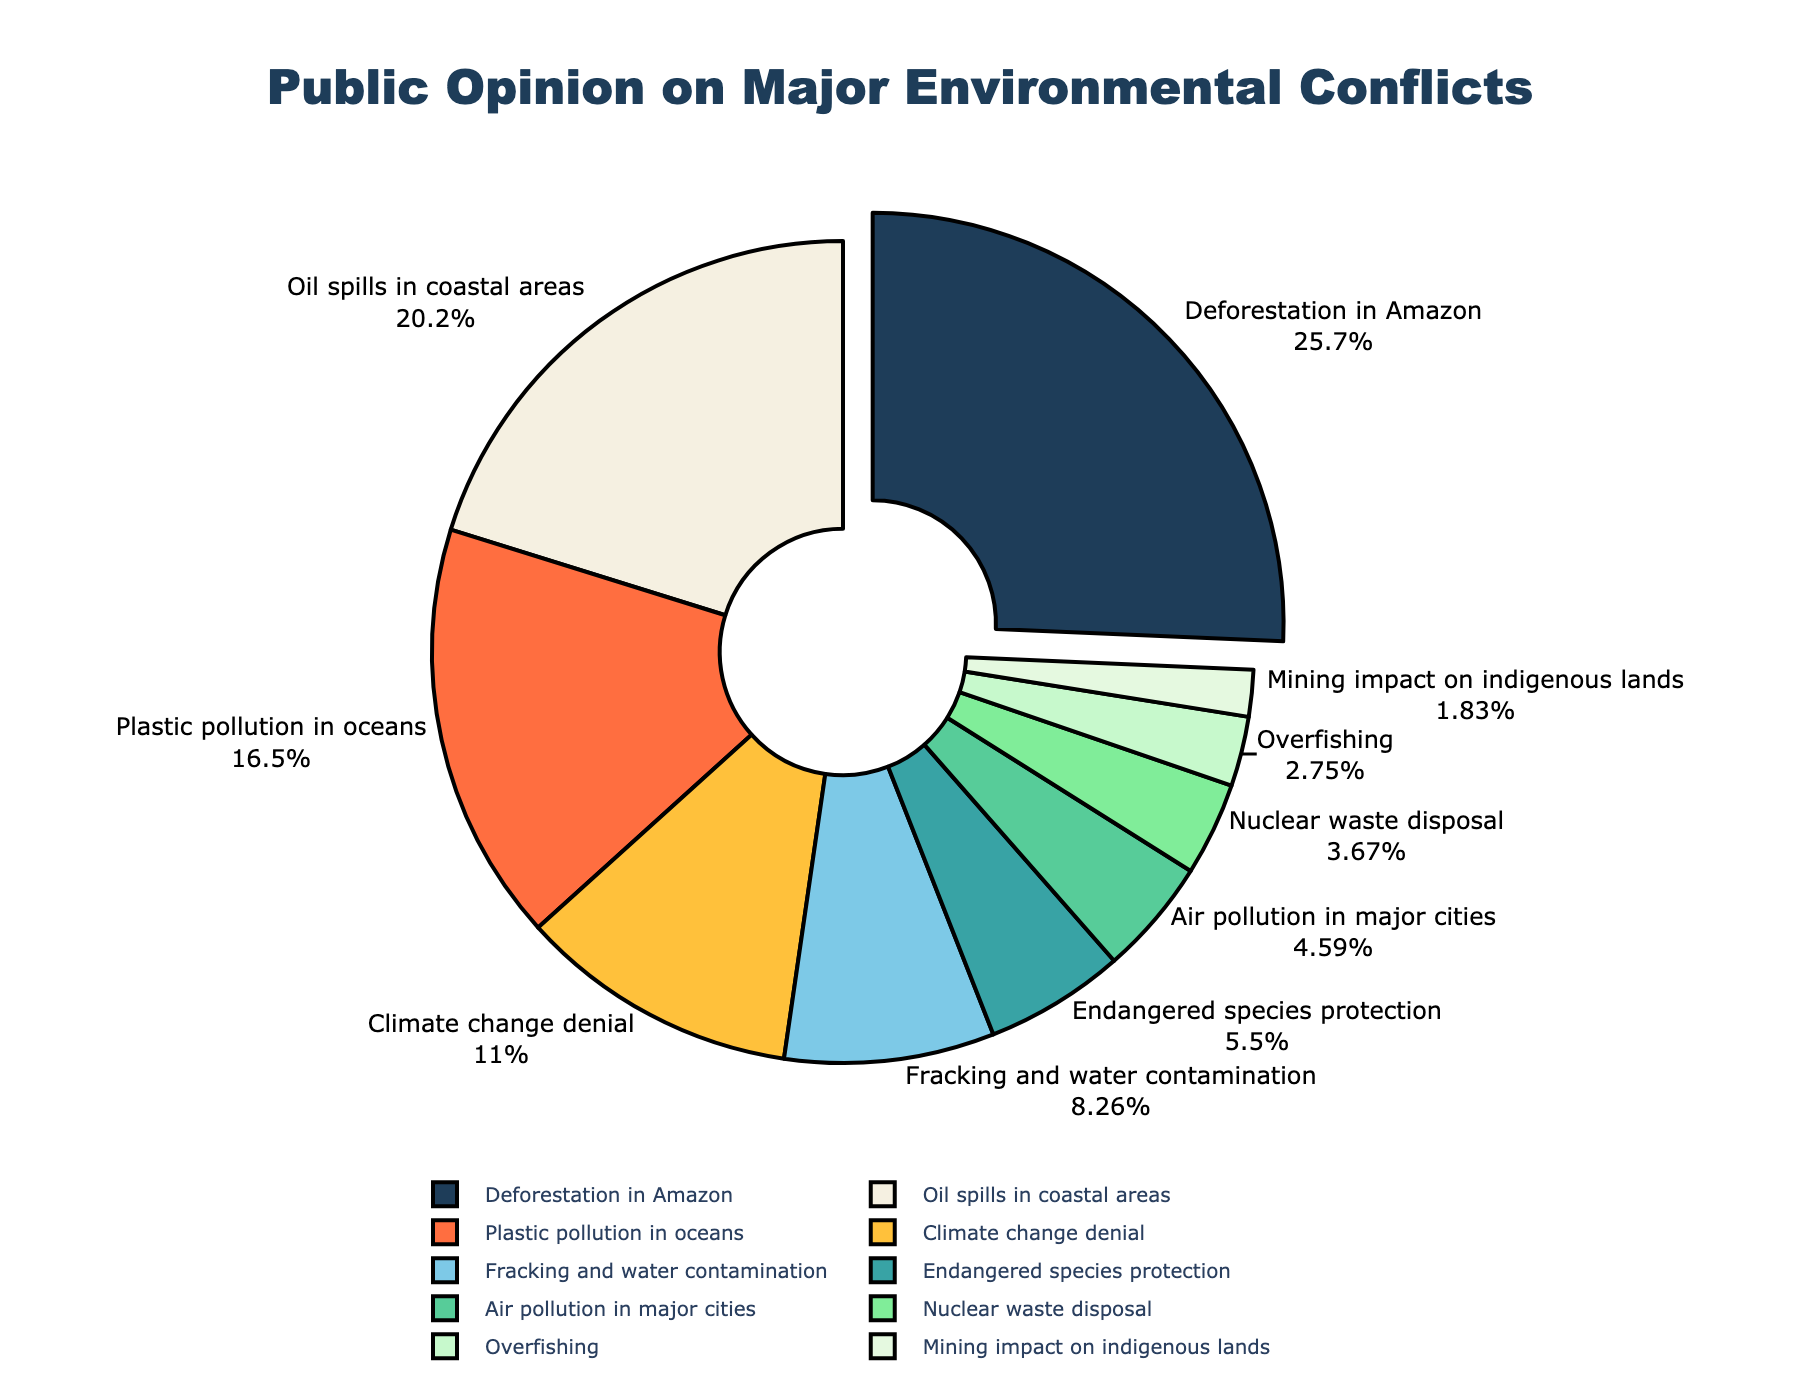Which environmental issue has the highest public concern? Referring to the figure, the largest portion of the pie chart, which is pulled out slightly from the rest, is for "Deforestation in Amazon" with 28%.
Answer: Deforestation in Amazon How much more concern is there for oil spills in coastal areas compared to fracking and water contamination? The percentage for oil spills in coastal areas is 22%, while for fracking and water contamination it is 9%. Subtracting these values, 22% - 9% = 13%.
Answer: 13% What is the combined percentage of concern for plastic pollution in oceans and climate change denial? The percentage for plastic pollution in oceans is 18%, and for climate change denial, it is 12%. Adding them, 18% + 12% = 30%.
Answer: 30% Which issue has a lower public concern: air pollution in major cities or nuclear waste disposal? Looking at the pie chart, air pollution in major cities has 5%, and nuclear waste disposal has 4%. Since 4% is less than 5%, nuclear waste disposal has a lower concern.
Answer: Nuclear waste disposal What fraction of the pie chart is dedicated to endangered species protection? Endangered species protection occupies 6% of the pie chart. To express this as a fraction, convert 6% to a fraction which is 6/100 or simplified to 3/50.
Answer: 3/50 How does public concern for overfishing compare to the concern for mining impact on indigenous lands? Overfishing has 3% and mining impact on indigenous lands has 2%. Since 3% is greater than 2%, overfishing is of more concern.
Answer: Overfishing What percentage of the pie chart corresponds to issues related to air pollution in major cities and nuclear waste disposal combined? The concern for air pollution in major cities is 5%, and for nuclear waste disposal, it is 4%. Adding them, 5% + 4% = 9%.
Answer: 9% If we combined the concerns for endangered species protection and mining impact on indigenous lands, how would it compare to fracking and water contamination? Endangered species protection is 6% and mining impact on indigenous lands is 2%. Combining them gives 6% + 2% = 8%. Fracking and water contamination is 9%. Thus, 8% < 9%, so it’s still less.
Answer: Less What is the color representing the concern for plastic pollution in oceans, and how is this represented in the pie chart? In the pie chart, plastic pollution in oceans is represented by the segment which occupies 18%. The color of this segment is a shade of orange.
Answer: Orange How significant is the slice representing mining impact on indigenous lands compared to the entire pie? Mining impact on indigenous lands is represented by 2% of the overall pie chart. Since this segment is a small portion compared to others, its significance is relatively low.
Answer: Relatively low 